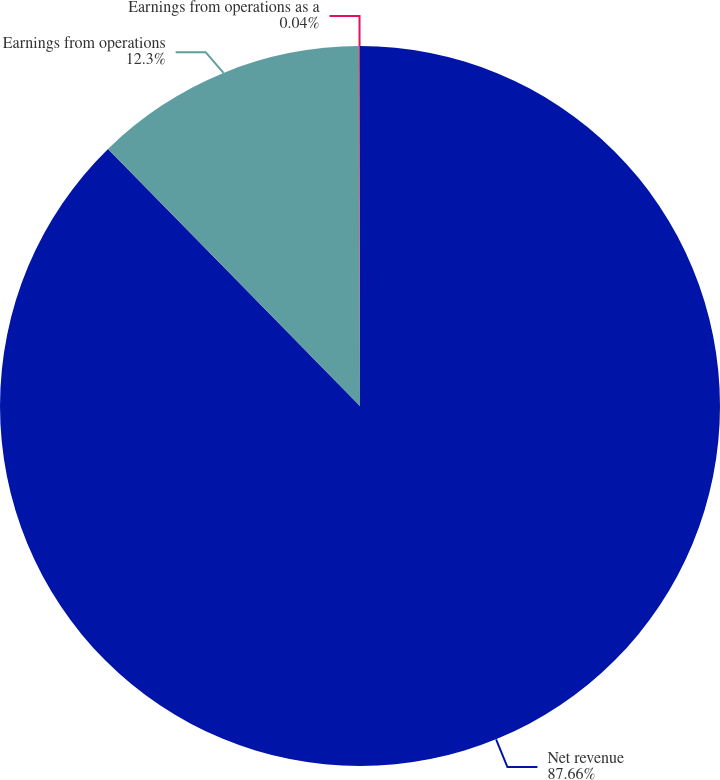<chart> <loc_0><loc_0><loc_500><loc_500><pie_chart><fcel>Net revenue<fcel>Earnings from operations<fcel>Earnings from operations as a<nl><fcel>87.66%<fcel>12.3%<fcel>0.04%<nl></chart> 